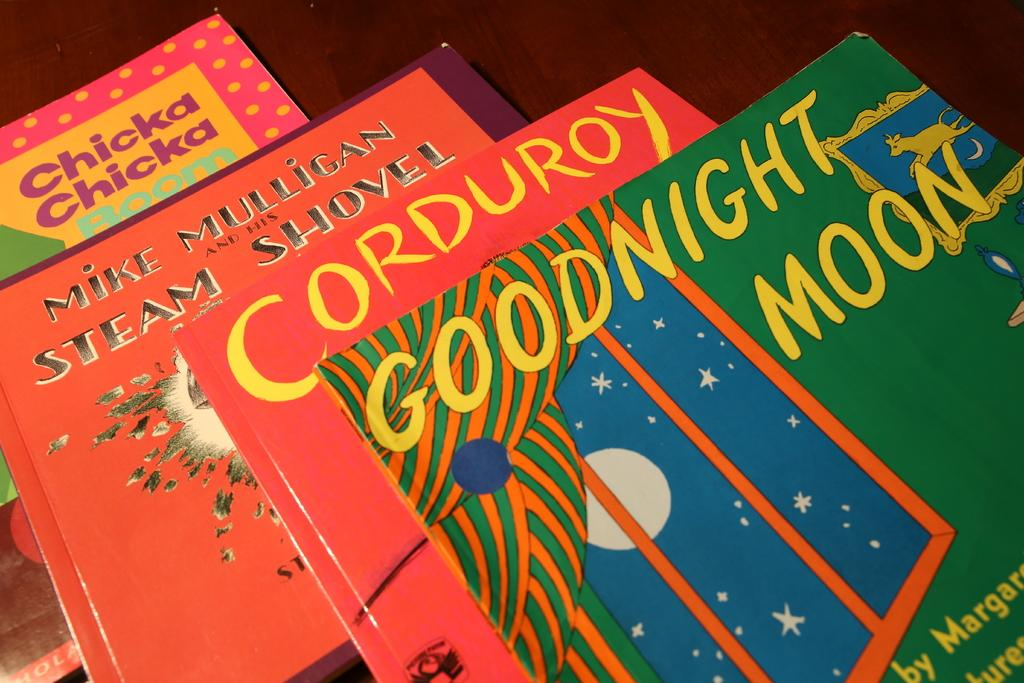<image>
Summarize the visual content of the image. Several books including Goodnight Moon are laid out on a table. 